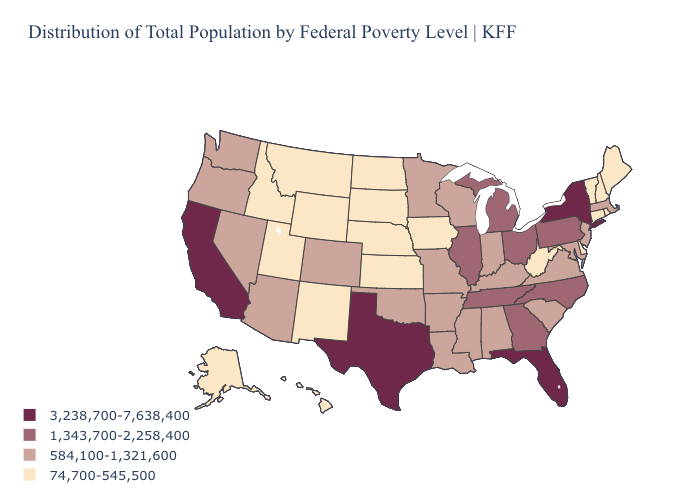Does the first symbol in the legend represent the smallest category?
Short answer required. No. Does Nevada have the highest value in the West?
Be succinct. No. Name the states that have a value in the range 3,238,700-7,638,400?
Short answer required. California, Florida, New York, Texas. What is the value of West Virginia?
Write a very short answer. 74,700-545,500. What is the highest value in the MidWest ?
Be succinct. 1,343,700-2,258,400. What is the value of Colorado?
Keep it brief. 584,100-1,321,600. Which states have the lowest value in the USA?
Give a very brief answer. Alaska, Connecticut, Delaware, Hawaii, Idaho, Iowa, Kansas, Maine, Montana, Nebraska, New Hampshire, New Mexico, North Dakota, Rhode Island, South Dakota, Utah, Vermont, West Virginia, Wyoming. Which states have the lowest value in the USA?
Give a very brief answer. Alaska, Connecticut, Delaware, Hawaii, Idaho, Iowa, Kansas, Maine, Montana, Nebraska, New Hampshire, New Mexico, North Dakota, Rhode Island, South Dakota, Utah, Vermont, West Virginia, Wyoming. Which states hav the highest value in the West?
Be succinct. California. Which states have the lowest value in the USA?
Be succinct. Alaska, Connecticut, Delaware, Hawaii, Idaho, Iowa, Kansas, Maine, Montana, Nebraska, New Hampshire, New Mexico, North Dakota, Rhode Island, South Dakota, Utah, Vermont, West Virginia, Wyoming. Among the states that border Mississippi , does Arkansas have the lowest value?
Answer briefly. Yes. What is the highest value in states that border Indiana?
Keep it brief. 1,343,700-2,258,400. Name the states that have a value in the range 1,343,700-2,258,400?
Be succinct. Georgia, Illinois, Michigan, North Carolina, Ohio, Pennsylvania, Tennessee. What is the value of Minnesota?
Be succinct. 584,100-1,321,600. Which states have the lowest value in the USA?
Give a very brief answer. Alaska, Connecticut, Delaware, Hawaii, Idaho, Iowa, Kansas, Maine, Montana, Nebraska, New Hampshire, New Mexico, North Dakota, Rhode Island, South Dakota, Utah, Vermont, West Virginia, Wyoming. 